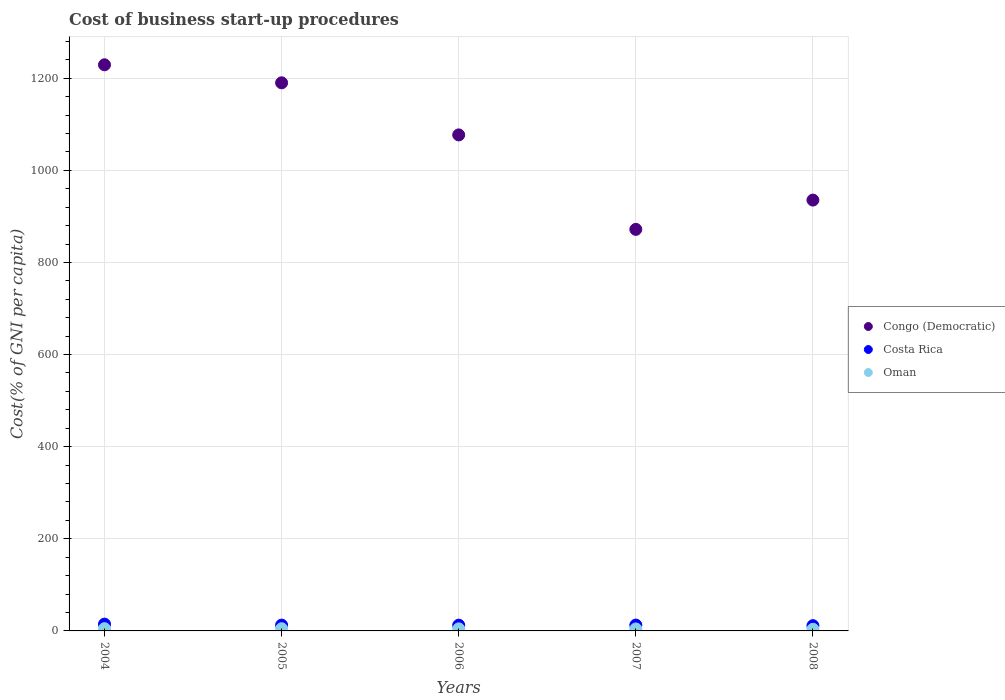How many different coloured dotlines are there?
Your answer should be very brief. 3. What is the cost of business start-up procedures in Congo (Democratic) in 2008?
Offer a terse response. 935.4. Across all years, what is the maximum cost of business start-up procedures in Congo (Democratic)?
Your answer should be very brief. 1229.1. Across all years, what is the minimum cost of business start-up procedures in Congo (Democratic)?
Your answer should be very brief. 871.8. What is the total cost of business start-up procedures in Congo (Democratic) in the graph?
Your response must be concise. 5303.2. What is the difference between the cost of business start-up procedures in Oman in 2006 and the cost of business start-up procedures in Costa Rica in 2004?
Ensure brevity in your answer.  -10.2. What is the average cost of business start-up procedures in Congo (Democratic) per year?
Keep it short and to the point. 1060.64. In the year 2008, what is the difference between the cost of business start-up procedures in Oman and cost of business start-up procedures in Costa Rica?
Provide a succinct answer. -7.8. What is the ratio of the cost of business start-up procedures in Costa Rica in 2005 to that in 2008?
Make the answer very short. 1.11. Is the cost of business start-up procedures in Costa Rica in 2004 less than that in 2005?
Keep it short and to the point. No. Is the difference between the cost of business start-up procedures in Oman in 2005 and 2007 greater than the difference between the cost of business start-up procedures in Costa Rica in 2005 and 2007?
Provide a succinct answer. Yes. What is the difference between the highest and the lowest cost of business start-up procedures in Oman?
Make the answer very short. 1.3. In how many years, is the cost of business start-up procedures in Costa Rica greater than the average cost of business start-up procedures in Costa Rica taken over all years?
Provide a short and direct response. 1. How many years are there in the graph?
Make the answer very short. 5. Are the values on the major ticks of Y-axis written in scientific E-notation?
Your response must be concise. No. Does the graph contain any zero values?
Your answer should be very brief. No. Does the graph contain grids?
Offer a terse response. Yes. Where does the legend appear in the graph?
Offer a terse response. Center right. What is the title of the graph?
Offer a very short reply. Cost of business start-up procedures. What is the label or title of the Y-axis?
Offer a terse response. Cost(% of GNI per capita). What is the Cost(% of GNI per capita) in Congo (Democratic) in 2004?
Make the answer very short. 1229.1. What is the Cost(% of GNI per capita) in Congo (Democratic) in 2005?
Your response must be concise. 1190. What is the Cost(% of GNI per capita) in Oman in 2005?
Make the answer very short. 4.8. What is the Cost(% of GNI per capita) of Congo (Democratic) in 2006?
Your response must be concise. 1076.9. What is the Cost(% of GNI per capita) in Congo (Democratic) in 2007?
Provide a succinct answer. 871.8. What is the Cost(% of GNI per capita) of Congo (Democratic) in 2008?
Keep it short and to the point. 935.4. What is the Cost(% of GNI per capita) of Costa Rica in 2008?
Your answer should be very brief. 11.4. Across all years, what is the maximum Cost(% of GNI per capita) in Congo (Democratic)?
Keep it short and to the point. 1229.1. Across all years, what is the maximum Cost(% of GNI per capita) in Costa Rica?
Offer a very short reply. 14.7. Across all years, what is the maximum Cost(% of GNI per capita) of Oman?
Your answer should be very brief. 4.9. Across all years, what is the minimum Cost(% of GNI per capita) of Congo (Democratic)?
Make the answer very short. 871.8. Across all years, what is the minimum Cost(% of GNI per capita) in Oman?
Your response must be concise. 3.6. What is the total Cost(% of GNI per capita) of Congo (Democratic) in the graph?
Your answer should be very brief. 5303.2. What is the total Cost(% of GNI per capita) in Costa Rica in the graph?
Your response must be concise. 63.9. What is the total Cost(% of GNI per capita) of Oman in the graph?
Your answer should be compact. 22.1. What is the difference between the Cost(% of GNI per capita) of Congo (Democratic) in 2004 and that in 2005?
Offer a terse response. 39.1. What is the difference between the Cost(% of GNI per capita) in Costa Rica in 2004 and that in 2005?
Make the answer very short. 2.1. What is the difference between the Cost(% of GNI per capita) of Oman in 2004 and that in 2005?
Provide a succinct answer. 0.1. What is the difference between the Cost(% of GNI per capita) in Congo (Democratic) in 2004 and that in 2006?
Keep it short and to the point. 152.2. What is the difference between the Cost(% of GNI per capita) in Congo (Democratic) in 2004 and that in 2007?
Provide a succinct answer. 357.3. What is the difference between the Cost(% of GNI per capita) in Costa Rica in 2004 and that in 2007?
Offer a very short reply. 2. What is the difference between the Cost(% of GNI per capita) in Congo (Democratic) in 2004 and that in 2008?
Make the answer very short. 293.7. What is the difference between the Cost(% of GNI per capita) of Oman in 2004 and that in 2008?
Make the answer very short. 1.3. What is the difference between the Cost(% of GNI per capita) of Congo (Democratic) in 2005 and that in 2006?
Your answer should be very brief. 113.1. What is the difference between the Cost(% of GNI per capita) of Costa Rica in 2005 and that in 2006?
Give a very brief answer. 0.1. What is the difference between the Cost(% of GNI per capita) in Congo (Democratic) in 2005 and that in 2007?
Offer a terse response. 318.2. What is the difference between the Cost(% of GNI per capita) in Costa Rica in 2005 and that in 2007?
Your answer should be compact. -0.1. What is the difference between the Cost(% of GNI per capita) in Congo (Democratic) in 2005 and that in 2008?
Offer a terse response. 254.6. What is the difference between the Cost(% of GNI per capita) of Costa Rica in 2005 and that in 2008?
Ensure brevity in your answer.  1.2. What is the difference between the Cost(% of GNI per capita) of Congo (Democratic) in 2006 and that in 2007?
Give a very brief answer. 205.1. What is the difference between the Cost(% of GNI per capita) of Costa Rica in 2006 and that in 2007?
Give a very brief answer. -0.2. What is the difference between the Cost(% of GNI per capita) of Congo (Democratic) in 2006 and that in 2008?
Your answer should be very brief. 141.5. What is the difference between the Cost(% of GNI per capita) in Oman in 2006 and that in 2008?
Your response must be concise. 0.9. What is the difference between the Cost(% of GNI per capita) of Congo (Democratic) in 2007 and that in 2008?
Your response must be concise. -63.6. What is the difference between the Cost(% of GNI per capita) of Costa Rica in 2007 and that in 2008?
Give a very brief answer. 1.3. What is the difference between the Cost(% of GNI per capita) in Congo (Democratic) in 2004 and the Cost(% of GNI per capita) in Costa Rica in 2005?
Your answer should be compact. 1216.5. What is the difference between the Cost(% of GNI per capita) in Congo (Democratic) in 2004 and the Cost(% of GNI per capita) in Oman in 2005?
Give a very brief answer. 1224.3. What is the difference between the Cost(% of GNI per capita) in Costa Rica in 2004 and the Cost(% of GNI per capita) in Oman in 2005?
Offer a very short reply. 9.9. What is the difference between the Cost(% of GNI per capita) of Congo (Democratic) in 2004 and the Cost(% of GNI per capita) of Costa Rica in 2006?
Give a very brief answer. 1216.6. What is the difference between the Cost(% of GNI per capita) of Congo (Democratic) in 2004 and the Cost(% of GNI per capita) of Oman in 2006?
Your answer should be compact. 1224.6. What is the difference between the Cost(% of GNI per capita) of Congo (Democratic) in 2004 and the Cost(% of GNI per capita) of Costa Rica in 2007?
Your answer should be very brief. 1216.4. What is the difference between the Cost(% of GNI per capita) in Congo (Democratic) in 2004 and the Cost(% of GNI per capita) in Oman in 2007?
Offer a very short reply. 1224.8. What is the difference between the Cost(% of GNI per capita) of Costa Rica in 2004 and the Cost(% of GNI per capita) of Oman in 2007?
Make the answer very short. 10.4. What is the difference between the Cost(% of GNI per capita) of Congo (Democratic) in 2004 and the Cost(% of GNI per capita) of Costa Rica in 2008?
Your answer should be compact. 1217.7. What is the difference between the Cost(% of GNI per capita) of Congo (Democratic) in 2004 and the Cost(% of GNI per capita) of Oman in 2008?
Your answer should be very brief. 1225.5. What is the difference between the Cost(% of GNI per capita) in Congo (Democratic) in 2005 and the Cost(% of GNI per capita) in Costa Rica in 2006?
Keep it short and to the point. 1177.5. What is the difference between the Cost(% of GNI per capita) in Congo (Democratic) in 2005 and the Cost(% of GNI per capita) in Oman in 2006?
Keep it short and to the point. 1185.5. What is the difference between the Cost(% of GNI per capita) in Costa Rica in 2005 and the Cost(% of GNI per capita) in Oman in 2006?
Provide a short and direct response. 8.1. What is the difference between the Cost(% of GNI per capita) of Congo (Democratic) in 2005 and the Cost(% of GNI per capita) of Costa Rica in 2007?
Your response must be concise. 1177.3. What is the difference between the Cost(% of GNI per capita) in Congo (Democratic) in 2005 and the Cost(% of GNI per capita) in Oman in 2007?
Your response must be concise. 1185.7. What is the difference between the Cost(% of GNI per capita) in Costa Rica in 2005 and the Cost(% of GNI per capita) in Oman in 2007?
Offer a very short reply. 8.3. What is the difference between the Cost(% of GNI per capita) of Congo (Democratic) in 2005 and the Cost(% of GNI per capita) of Costa Rica in 2008?
Provide a succinct answer. 1178.6. What is the difference between the Cost(% of GNI per capita) in Congo (Democratic) in 2005 and the Cost(% of GNI per capita) in Oman in 2008?
Ensure brevity in your answer.  1186.4. What is the difference between the Cost(% of GNI per capita) in Costa Rica in 2005 and the Cost(% of GNI per capita) in Oman in 2008?
Provide a succinct answer. 9. What is the difference between the Cost(% of GNI per capita) of Congo (Democratic) in 2006 and the Cost(% of GNI per capita) of Costa Rica in 2007?
Your answer should be very brief. 1064.2. What is the difference between the Cost(% of GNI per capita) of Congo (Democratic) in 2006 and the Cost(% of GNI per capita) of Oman in 2007?
Keep it short and to the point. 1072.6. What is the difference between the Cost(% of GNI per capita) of Costa Rica in 2006 and the Cost(% of GNI per capita) of Oman in 2007?
Provide a succinct answer. 8.2. What is the difference between the Cost(% of GNI per capita) of Congo (Democratic) in 2006 and the Cost(% of GNI per capita) of Costa Rica in 2008?
Offer a very short reply. 1065.5. What is the difference between the Cost(% of GNI per capita) of Congo (Democratic) in 2006 and the Cost(% of GNI per capita) of Oman in 2008?
Your response must be concise. 1073.3. What is the difference between the Cost(% of GNI per capita) of Congo (Democratic) in 2007 and the Cost(% of GNI per capita) of Costa Rica in 2008?
Provide a succinct answer. 860.4. What is the difference between the Cost(% of GNI per capita) of Congo (Democratic) in 2007 and the Cost(% of GNI per capita) of Oman in 2008?
Provide a short and direct response. 868.2. What is the average Cost(% of GNI per capita) in Congo (Democratic) per year?
Make the answer very short. 1060.64. What is the average Cost(% of GNI per capita) in Costa Rica per year?
Your response must be concise. 12.78. What is the average Cost(% of GNI per capita) of Oman per year?
Provide a short and direct response. 4.42. In the year 2004, what is the difference between the Cost(% of GNI per capita) of Congo (Democratic) and Cost(% of GNI per capita) of Costa Rica?
Ensure brevity in your answer.  1214.4. In the year 2004, what is the difference between the Cost(% of GNI per capita) of Congo (Democratic) and Cost(% of GNI per capita) of Oman?
Offer a terse response. 1224.2. In the year 2004, what is the difference between the Cost(% of GNI per capita) in Costa Rica and Cost(% of GNI per capita) in Oman?
Your response must be concise. 9.8. In the year 2005, what is the difference between the Cost(% of GNI per capita) of Congo (Democratic) and Cost(% of GNI per capita) of Costa Rica?
Give a very brief answer. 1177.4. In the year 2005, what is the difference between the Cost(% of GNI per capita) in Congo (Democratic) and Cost(% of GNI per capita) in Oman?
Provide a succinct answer. 1185.2. In the year 2006, what is the difference between the Cost(% of GNI per capita) in Congo (Democratic) and Cost(% of GNI per capita) in Costa Rica?
Ensure brevity in your answer.  1064.4. In the year 2006, what is the difference between the Cost(% of GNI per capita) in Congo (Democratic) and Cost(% of GNI per capita) in Oman?
Give a very brief answer. 1072.4. In the year 2007, what is the difference between the Cost(% of GNI per capita) in Congo (Democratic) and Cost(% of GNI per capita) in Costa Rica?
Offer a very short reply. 859.1. In the year 2007, what is the difference between the Cost(% of GNI per capita) of Congo (Democratic) and Cost(% of GNI per capita) of Oman?
Offer a terse response. 867.5. In the year 2007, what is the difference between the Cost(% of GNI per capita) of Costa Rica and Cost(% of GNI per capita) of Oman?
Your answer should be very brief. 8.4. In the year 2008, what is the difference between the Cost(% of GNI per capita) of Congo (Democratic) and Cost(% of GNI per capita) of Costa Rica?
Give a very brief answer. 924. In the year 2008, what is the difference between the Cost(% of GNI per capita) in Congo (Democratic) and Cost(% of GNI per capita) in Oman?
Make the answer very short. 931.8. What is the ratio of the Cost(% of GNI per capita) of Congo (Democratic) in 2004 to that in 2005?
Make the answer very short. 1.03. What is the ratio of the Cost(% of GNI per capita) of Oman in 2004 to that in 2005?
Provide a succinct answer. 1.02. What is the ratio of the Cost(% of GNI per capita) of Congo (Democratic) in 2004 to that in 2006?
Provide a succinct answer. 1.14. What is the ratio of the Cost(% of GNI per capita) in Costa Rica in 2004 to that in 2006?
Offer a very short reply. 1.18. What is the ratio of the Cost(% of GNI per capita) in Oman in 2004 to that in 2006?
Make the answer very short. 1.09. What is the ratio of the Cost(% of GNI per capita) of Congo (Democratic) in 2004 to that in 2007?
Provide a short and direct response. 1.41. What is the ratio of the Cost(% of GNI per capita) of Costa Rica in 2004 to that in 2007?
Your answer should be very brief. 1.16. What is the ratio of the Cost(% of GNI per capita) of Oman in 2004 to that in 2007?
Ensure brevity in your answer.  1.14. What is the ratio of the Cost(% of GNI per capita) of Congo (Democratic) in 2004 to that in 2008?
Your answer should be very brief. 1.31. What is the ratio of the Cost(% of GNI per capita) of Costa Rica in 2004 to that in 2008?
Your answer should be compact. 1.29. What is the ratio of the Cost(% of GNI per capita) in Oman in 2004 to that in 2008?
Offer a very short reply. 1.36. What is the ratio of the Cost(% of GNI per capita) of Congo (Democratic) in 2005 to that in 2006?
Offer a terse response. 1.1. What is the ratio of the Cost(% of GNI per capita) of Costa Rica in 2005 to that in 2006?
Give a very brief answer. 1.01. What is the ratio of the Cost(% of GNI per capita) of Oman in 2005 to that in 2006?
Keep it short and to the point. 1.07. What is the ratio of the Cost(% of GNI per capita) in Congo (Democratic) in 2005 to that in 2007?
Offer a very short reply. 1.36. What is the ratio of the Cost(% of GNI per capita) in Costa Rica in 2005 to that in 2007?
Offer a terse response. 0.99. What is the ratio of the Cost(% of GNI per capita) of Oman in 2005 to that in 2007?
Your answer should be very brief. 1.12. What is the ratio of the Cost(% of GNI per capita) in Congo (Democratic) in 2005 to that in 2008?
Provide a succinct answer. 1.27. What is the ratio of the Cost(% of GNI per capita) of Costa Rica in 2005 to that in 2008?
Ensure brevity in your answer.  1.11. What is the ratio of the Cost(% of GNI per capita) of Oman in 2005 to that in 2008?
Keep it short and to the point. 1.33. What is the ratio of the Cost(% of GNI per capita) in Congo (Democratic) in 2006 to that in 2007?
Give a very brief answer. 1.24. What is the ratio of the Cost(% of GNI per capita) of Costa Rica in 2006 to that in 2007?
Give a very brief answer. 0.98. What is the ratio of the Cost(% of GNI per capita) in Oman in 2006 to that in 2007?
Give a very brief answer. 1.05. What is the ratio of the Cost(% of GNI per capita) of Congo (Democratic) in 2006 to that in 2008?
Provide a succinct answer. 1.15. What is the ratio of the Cost(% of GNI per capita) in Costa Rica in 2006 to that in 2008?
Provide a succinct answer. 1.1. What is the ratio of the Cost(% of GNI per capita) of Oman in 2006 to that in 2008?
Your answer should be compact. 1.25. What is the ratio of the Cost(% of GNI per capita) of Congo (Democratic) in 2007 to that in 2008?
Keep it short and to the point. 0.93. What is the ratio of the Cost(% of GNI per capita) in Costa Rica in 2007 to that in 2008?
Offer a terse response. 1.11. What is the ratio of the Cost(% of GNI per capita) of Oman in 2007 to that in 2008?
Ensure brevity in your answer.  1.19. What is the difference between the highest and the second highest Cost(% of GNI per capita) in Congo (Democratic)?
Provide a short and direct response. 39.1. What is the difference between the highest and the second highest Cost(% of GNI per capita) in Costa Rica?
Give a very brief answer. 2. What is the difference between the highest and the second highest Cost(% of GNI per capita) in Oman?
Offer a very short reply. 0.1. What is the difference between the highest and the lowest Cost(% of GNI per capita) in Congo (Democratic)?
Keep it short and to the point. 357.3. 